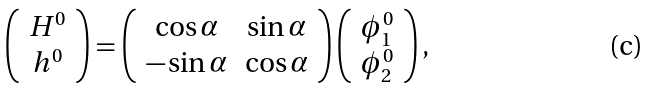Convert formula to latex. <formula><loc_0><loc_0><loc_500><loc_500>\left ( \begin{array} { c } H ^ { 0 } \\ h ^ { 0 } \\ \end{array} \right ) = \left ( \begin{array} { c c } \cos \alpha & \sin \alpha \\ - \sin \alpha & \cos \alpha \\ \end{array} \right ) \left ( \begin{array} { c } \phi _ { 1 } ^ { 0 } \\ \phi _ { 2 } ^ { 0 } \\ \end{array} \right ) ,</formula> 